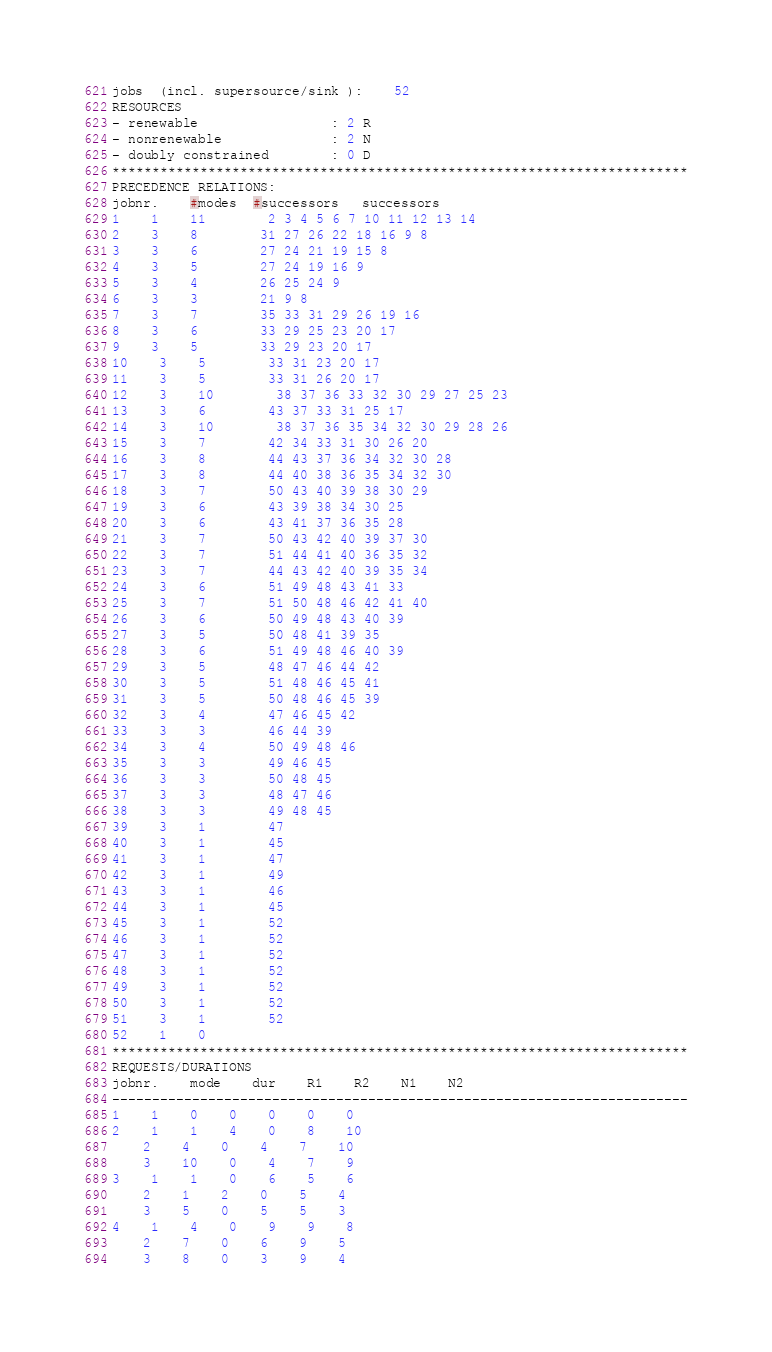Convert code to text. <code><loc_0><loc_0><loc_500><loc_500><_ObjectiveC_>jobs  (incl. supersource/sink ):	52
RESOURCES
- renewable                 : 2 R
- nonrenewable              : 2 N
- doubly constrained        : 0 D
************************************************************************
PRECEDENCE RELATIONS:
jobnr.    #modes  #successors   successors
1	1	11		2 3 4 5 6 7 10 11 12 13 14 
2	3	8		31 27 26 22 18 16 9 8 
3	3	6		27 24 21 19 15 8 
4	3	5		27 24 19 16 9 
5	3	4		26 25 24 9 
6	3	3		21 9 8 
7	3	7		35 33 31 29 26 19 16 
8	3	6		33 29 25 23 20 17 
9	3	5		33 29 23 20 17 
10	3	5		33 31 23 20 17 
11	3	5		33 31 26 20 17 
12	3	10		38 37 36 33 32 30 29 27 25 23 
13	3	6		43 37 33 31 25 17 
14	3	10		38 37 36 35 34 32 30 29 28 26 
15	3	7		42 34 33 31 30 26 20 
16	3	8		44 43 37 36 34 32 30 28 
17	3	8		44 40 38 36 35 34 32 30 
18	3	7		50 43 40 39 38 30 29 
19	3	6		43 39 38 34 30 25 
20	3	6		43 41 37 36 35 28 
21	3	7		50 43 42 40 39 37 30 
22	3	7		51 44 41 40 36 35 32 
23	3	7		44 43 42 40 39 35 34 
24	3	6		51 49 48 43 41 33 
25	3	7		51 50 48 46 42 41 40 
26	3	6		50 49 48 43 40 39 
27	3	5		50 48 41 39 35 
28	3	6		51 49 48 46 40 39 
29	3	5		48 47 46 44 42 
30	3	5		51 48 46 45 41 
31	3	5		50 48 46 45 39 
32	3	4		47 46 45 42 
33	3	3		46 44 39 
34	3	4		50 49 48 46 
35	3	3		49 46 45 
36	3	3		50 48 45 
37	3	3		48 47 46 
38	3	3		49 48 45 
39	3	1		47 
40	3	1		45 
41	3	1		47 
42	3	1		49 
43	3	1		46 
44	3	1		45 
45	3	1		52 
46	3	1		52 
47	3	1		52 
48	3	1		52 
49	3	1		52 
50	3	1		52 
51	3	1		52 
52	1	0		
************************************************************************
REQUESTS/DURATIONS
jobnr.	mode	dur	R1	R2	N1	N2	
------------------------------------------------------------------------
1	1	0	0	0	0	0	
2	1	1	4	0	8	10	
	2	4	0	4	7	10	
	3	10	0	4	7	9	
3	1	1	0	6	5	6	
	2	1	2	0	5	4	
	3	5	0	5	5	3	
4	1	4	0	9	9	8	
	2	7	0	6	9	5	
	3	8	0	3	9	4	</code> 